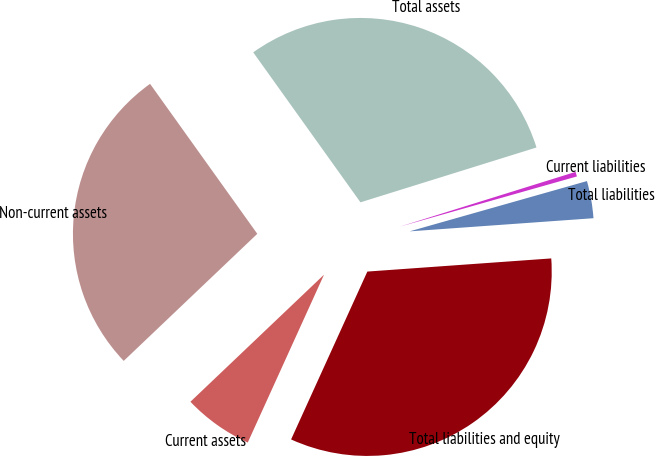<chart> <loc_0><loc_0><loc_500><loc_500><pie_chart><fcel>Current assets<fcel>Non-current assets<fcel>Total assets<fcel>Current liabilities<fcel>Total liabilities<fcel>Total liabilities and equity<nl><fcel>6.11%<fcel>27.22%<fcel>30.07%<fcel>0.41%<fcel>3.26%<fcel>32.92%<nl></chart> 